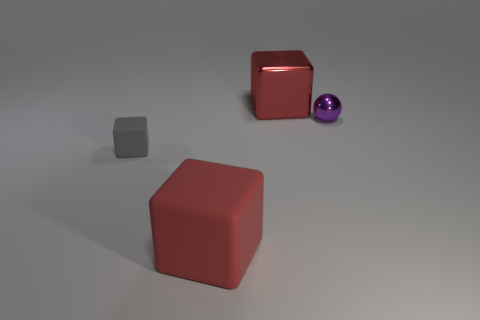Assuming the purple sphere is moved towards the big gray cube, which one would be in front? If the purple sphere is moved towards the big gray cube following the perspective of the image, the sphere would end up in front of the cube. 